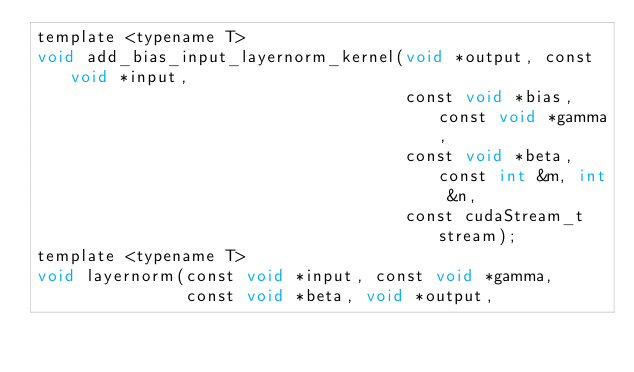Convert code to text. <code><loc_0><loc_0><loc_500><loc_500><_Cuda_>template <typename T>
void add_bias_input_layernorm_kernel(void *output, const void *input,
                                     const void *bias, const void *gamma,
                                     const void *beta, const int &m, int &n,
                                     const cudaStream_t stream);
template <typename T>
void layernorm(const void *input, const void *gamma,
               const void *beta, void *output,</code> 